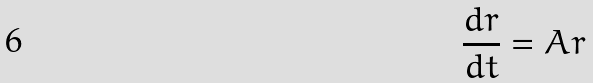Convert formula to latex. <formula><loc_0><loc_0><loc_500><loc_500>\frac { d r } { d t } = A r</formula> 